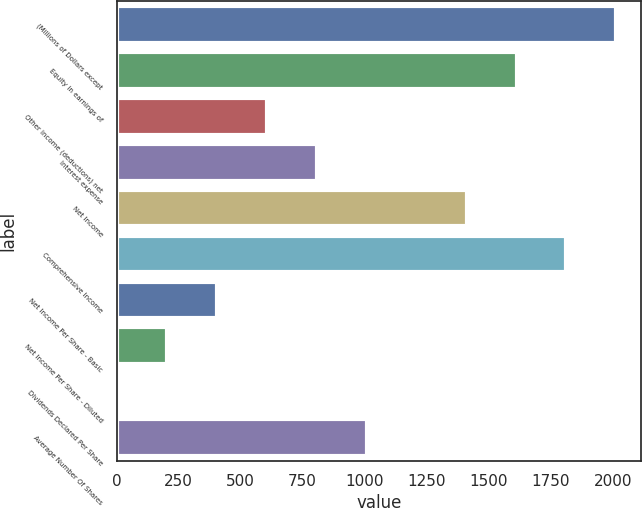Convert chart to OTSL. <chart><loc_0><loc_0><loc_500><loc_500><bar_chart><fcel>(Millions of Dollars except<fcel>Equity in earnings of<fcel>Other income (deductions) net<fcel>Interest expense<fcel>Net Income<fcel>Comprehensive Income<fcel>Net Income Per Share - Basic<fcel>Net Income Per Share - Diluted<fcel>Dividends Declared Per Share<fcel>Average Number Of Shares<nl><fcel>2015<fcel>1612.52<fcel>606.32<fcel>807.56<fcel>1411.28<fcel>1813.76<fcel>405.08<fcel>203.84<fcel>2.6<fcel>1008.8<nl></chart> 